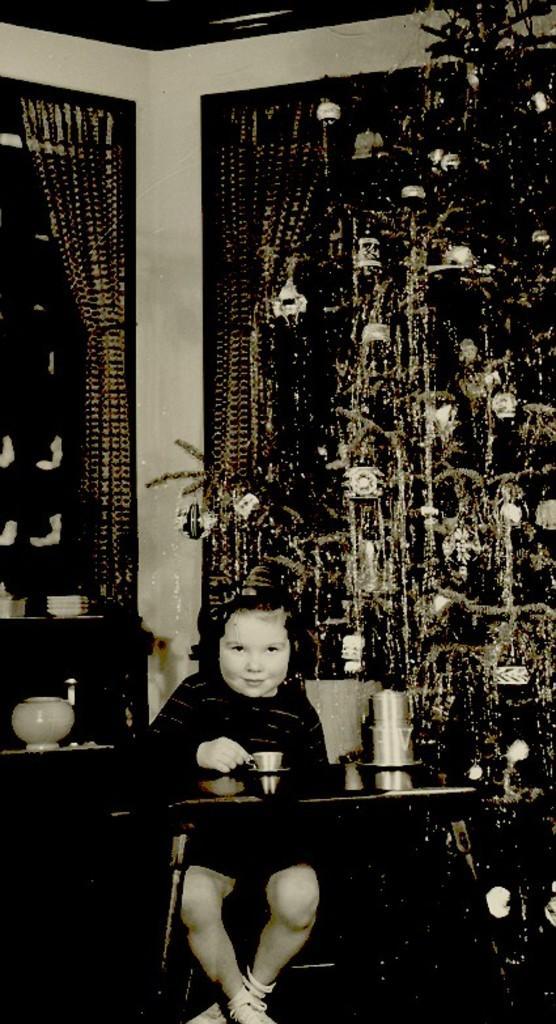Could you give a brief overview of what you see in this image? As we can see in the image there is a Christmas tree, curtains, a boy sitting on chair and table. On table there are glasses and cup. 